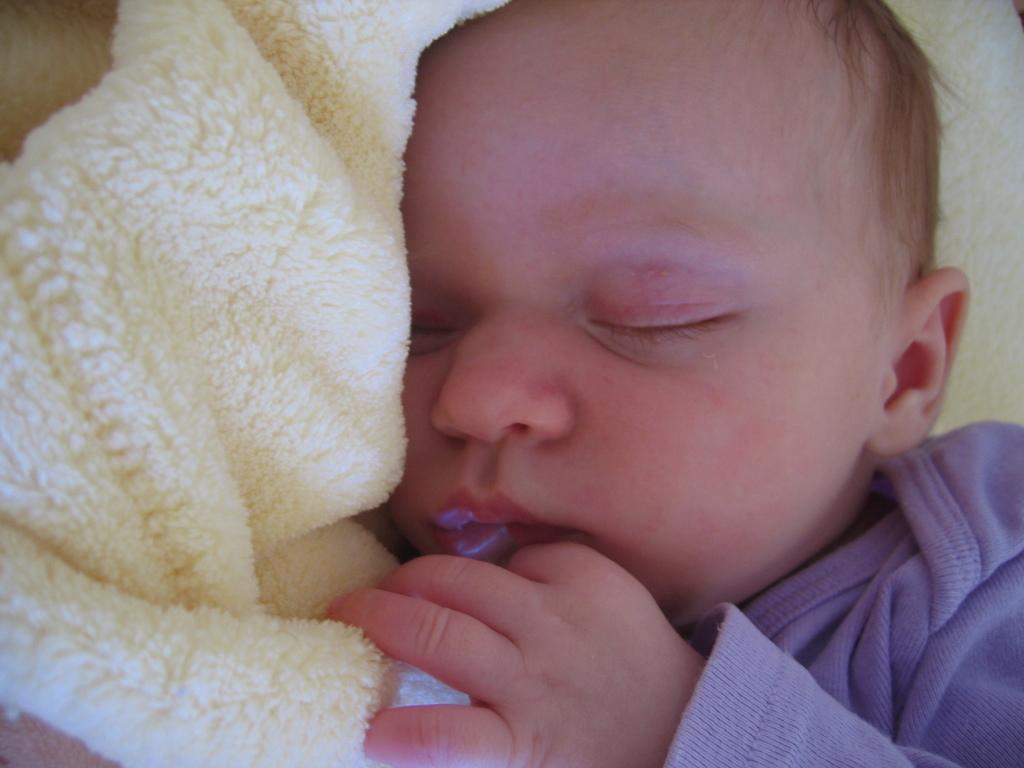In one or two sentences, can you explain what this image depicts? In this image we can see a kid wearing blue color dress sleeping in a towel which is of cream color. 